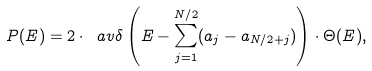<formula> <loc_0><loc_0><loc_500><loc_500>P ( E ) = 2 \cdot \ a v { \delta \left ( E - \sum _ { j = 1 } ^ { N / 2 } ( a _ { j } - a _ { N / 2 + j } ) \right ) } \cdot \Theta ( E ) ,</formula> 